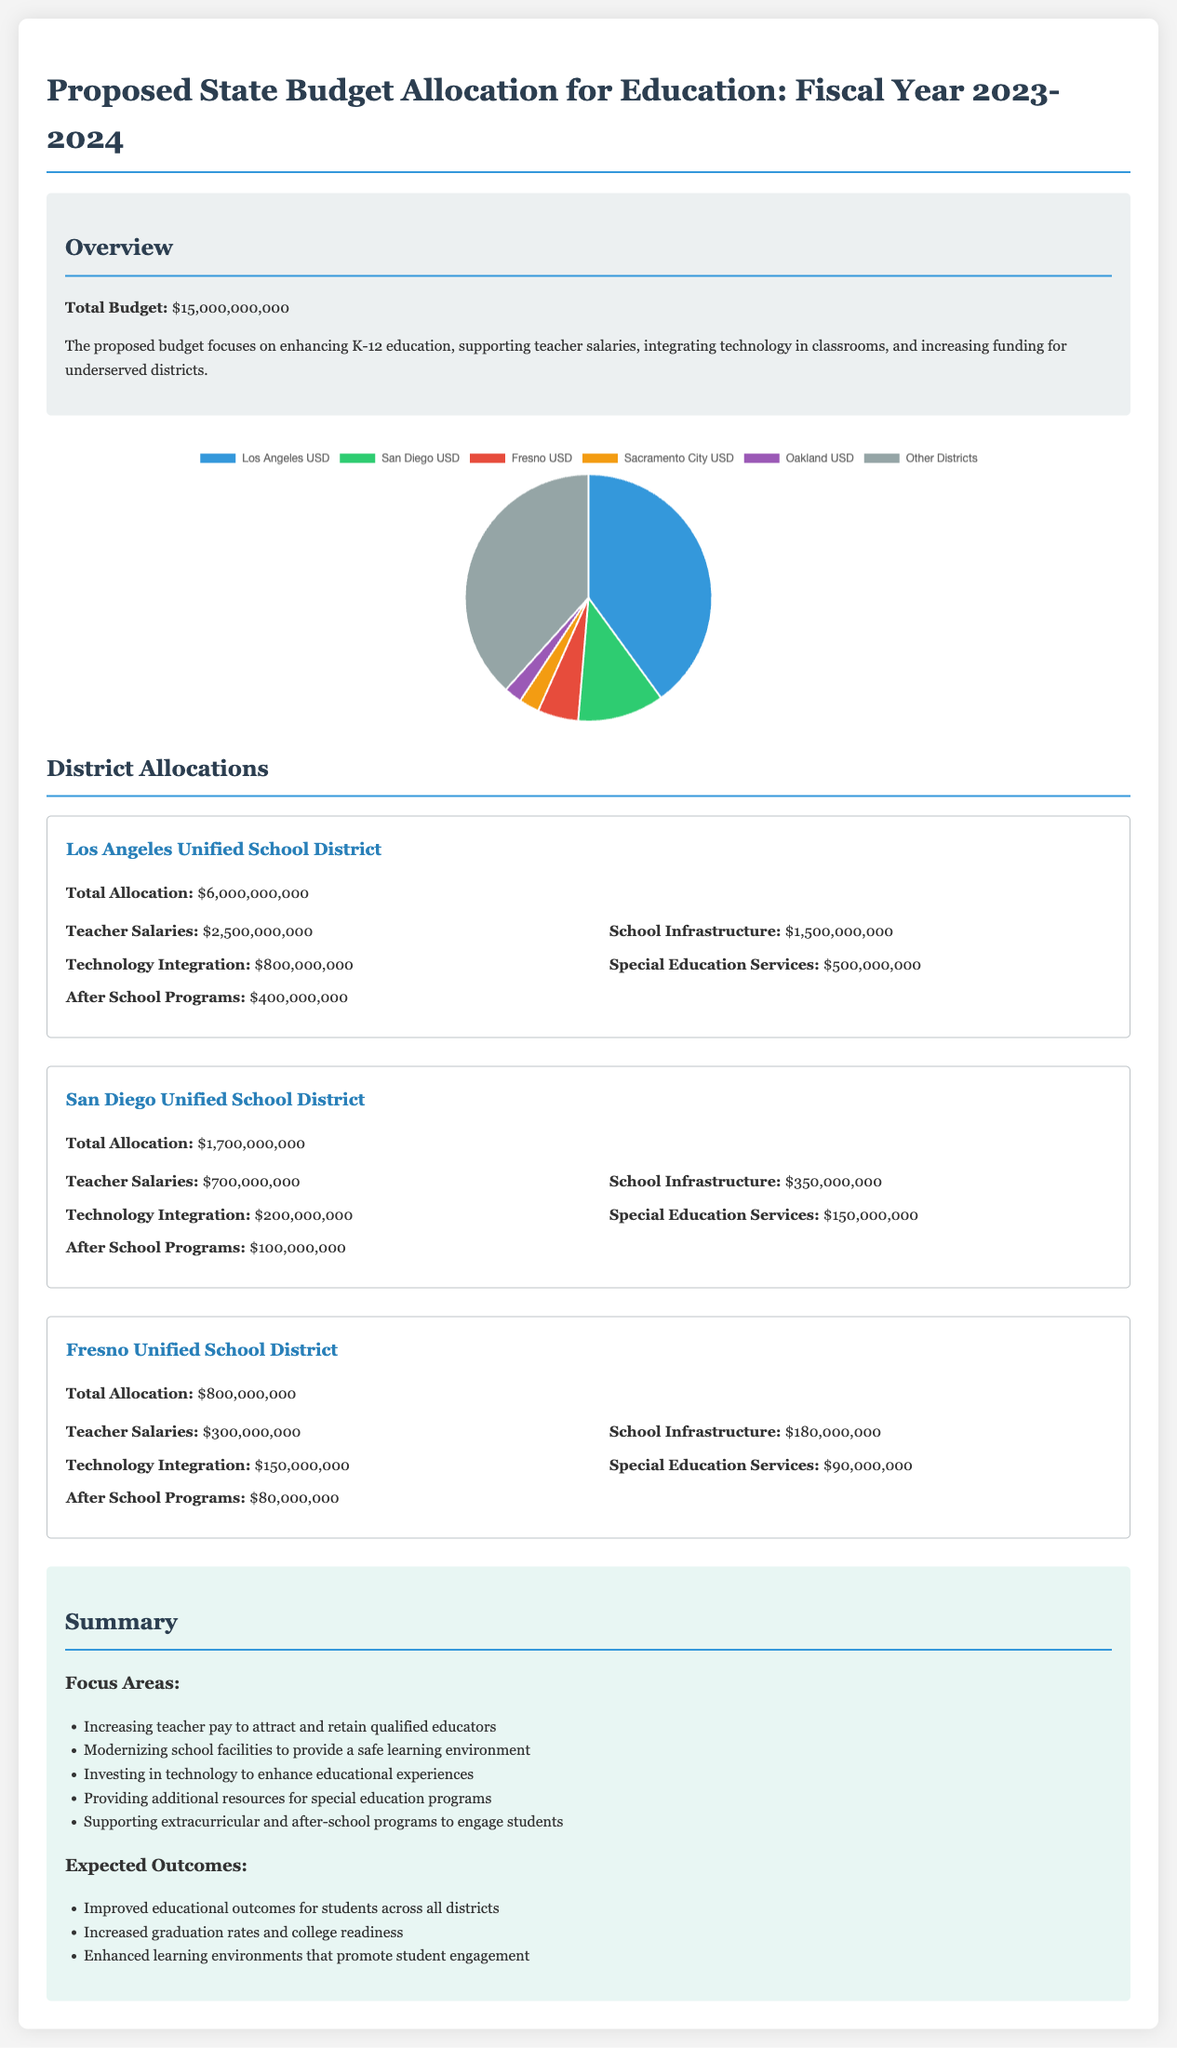What is the total budget for education in fiscal year 2023-2024? The total budget is explicitly stated in the document as $15,000,000,000.
Answer: $15,000,000,000 What is the allocation for Los Angeles Unified School District? The document specifies that the total allocation for Los Angeles Unified School District is $6,000,000,000.
Answer: $6,000,000,000 Which district has the second highest budget allocation? The San Diego Unified School District has the second highest allocation after Los Angeles.
Answer: San Diego Unified School District How much is allocated for teacher salaries in Fresno Unified School District? The document provides the figure for teacher salaries at Fresno Unified as $300,000,000.
Answer: $300,000,000 What percentage of the total budget is allocated to Los Angeles Unified School District? The allocation for Los Angeles Unified is $6,000,000,000 out of a total of $15,000,000,000, which can be calculated as 40%.
Answer: 40% What is the budget for technology integration in San Diego Unified School District? The document states that the budget for technology integration in San Diego Unified is $200,000,000.
Answer: $200,000,000 How much is being spent on school infrastructure across all mentioned districts? The total for school infrastructure includes $1,500,000,000 (Los Angeles) + $350,000,000 (San Diego) + $180,000,000 (Fresno), totaling $2,030,000,000.
Answer: $2,030,000,000 What are the expected outcomes mentioned in the summary? The document lists improved educational outcomes, increased graduation rates, and enhanced learning environments as expected outcomes.
Answer: Improved educational outcomes, increased graduation rates, enhanced learning environments What is the focus area related to after-school programs? Supporting extracurricular and after-school programs to engage students is the focus area related to after-school programs.
Answer: Supporting extracurricular and after-school programs to engage students 